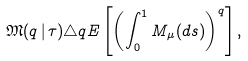Convert formula to latex. <formula><loc_0><loc_0><loc_500><loc_500>\mathfrak { M } ( q \, | \, \tau ) \triangle q { E } \left [ \left ( \int _ { 0 } ^ { 1 } M _ { \mu } ( d s ) \right ) ^ { q } \right ] ,</formula> 